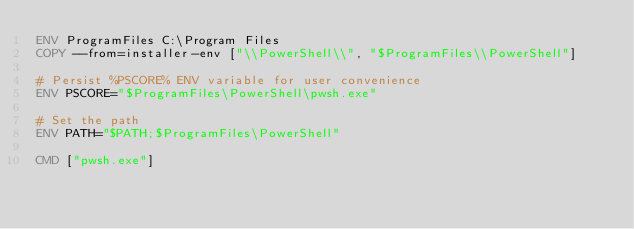Convert code to text. <code><loc_0><loc_0><loc_500><loc_500><_Dockerfile_>ENV ProgramFiles C:\Program Files
COPY --from=installer-env ["\\PowerShell\\", "$ProgramFiles\\PowerShell"]

# Persist %PSCORE% ENV variable for user convenience
ENV PSCORE="$ProgramFiles\PowerShell\pwsh.exe"

# Set the path
ENV PATH="$PATH;$ProgramFiles\PowerShell"

CMD ["pwsh.exe"]
</code> 